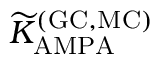<formula> <loc_0><loc_0><loc_500><loc_500>{ \widetilde { K } } _ { A M P A } ^ { ( G C , M C ) }</formula> 